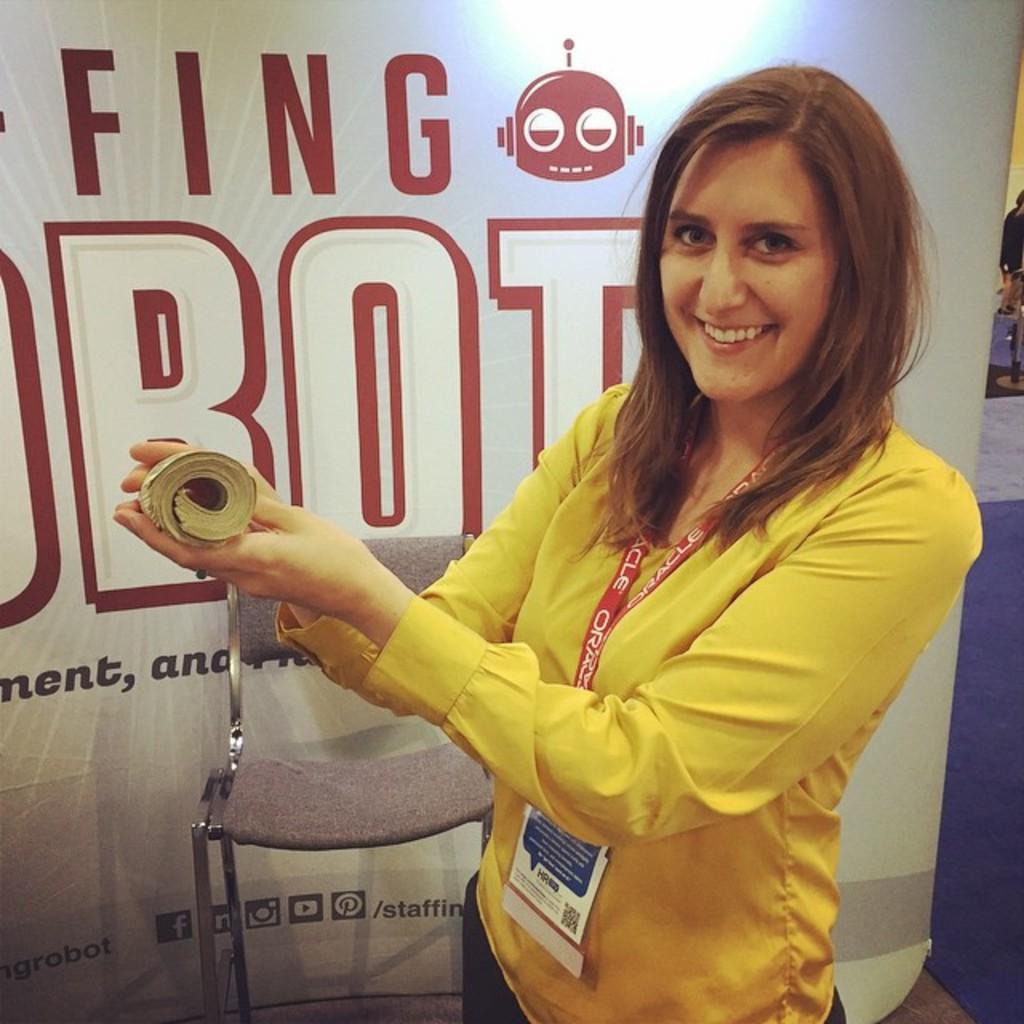How would you summarize this image in a sentence or two? A woman is standing wearing a yellow shirt and id card. She is holding a book in her hand. There is a chair and a banner at the back. 